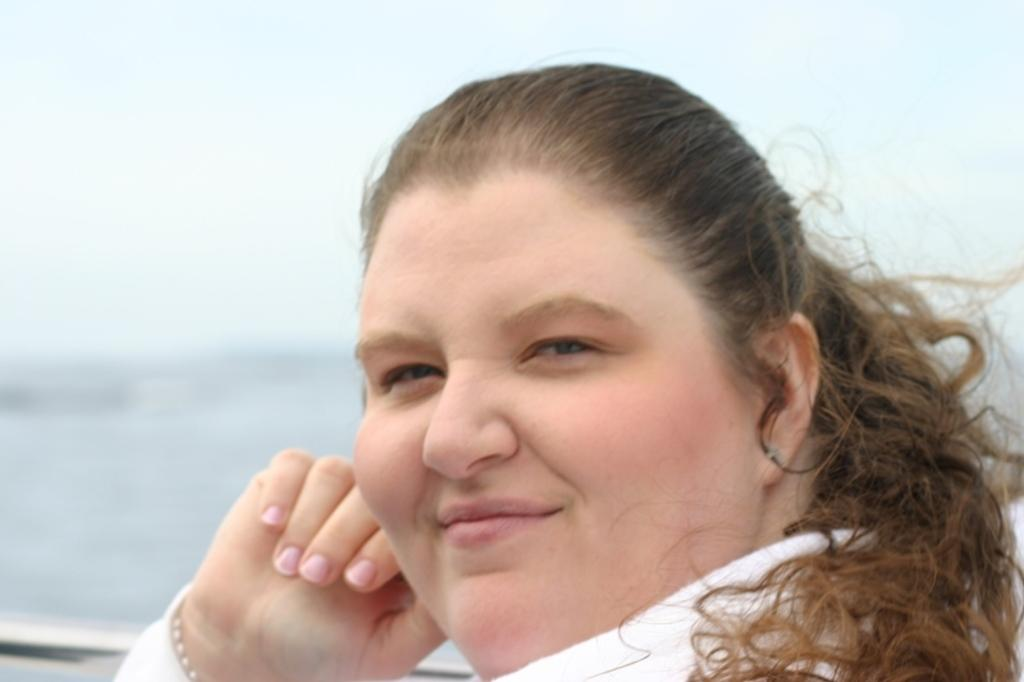What is the main subject of the image? There is a person in the image. Can you describe the person's clothing? The person is wearing white clothing. What expression does the person have? The person is smiling. What color is the background of the image? The background of the image is white. How much money is the person holding in the image? There is no indication of money in the image; the person is wearing white clothing and smiling against a white background. 